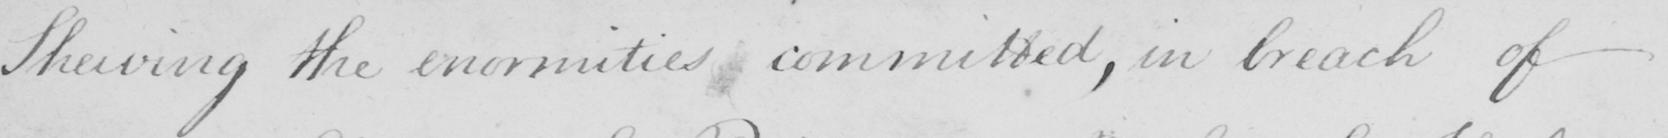Please provide the text content of this handwritten line. Shewing the enormities committed , in breach of 